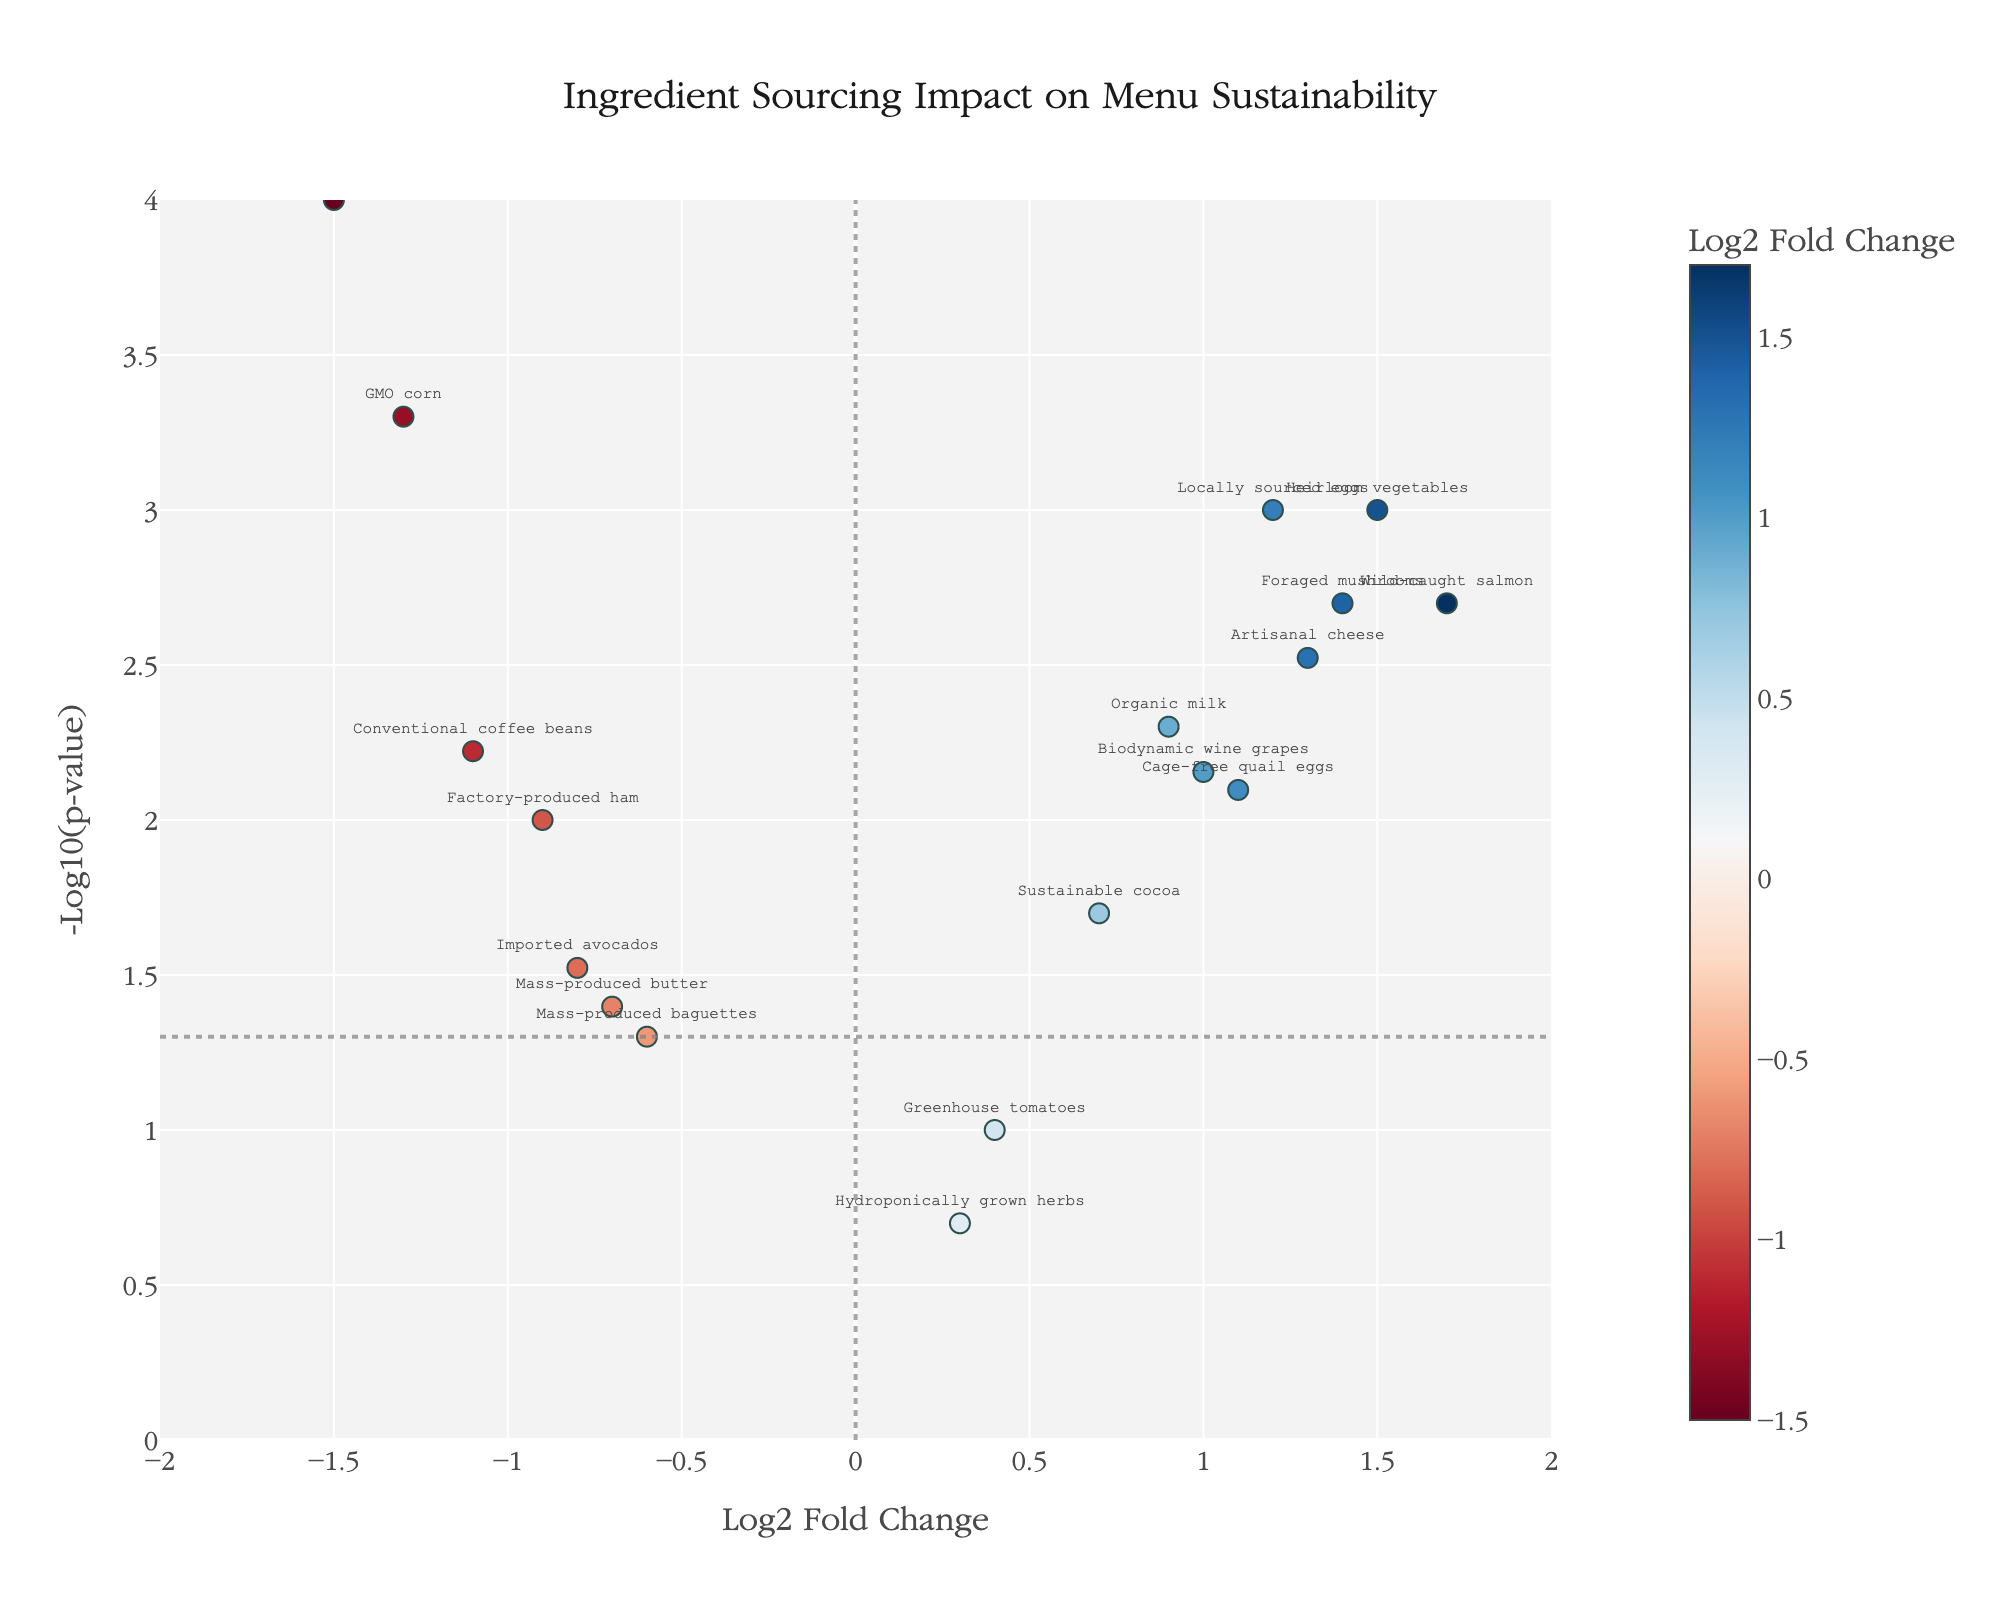What's the title of this figure? The title is typically positioned at the top center of the figure. The text in this position is "Ingredient Sourcing Impact on Menu Sustainability"
Answer: Ingredient Sourcing Impact on Menu Sustainability On which axis can I find the "Log2 Fold Change"? The 'Log2 Fold Change' is mentioned on one of the axis titles. The x-axis title is "Log2 Fold Change".
Answer: X-axis Which ingredient has the highest log2FoldChange value? By inspecting the x-axis, the ingredient with the highest positive value on the rightmost side is "Wild-caught salmon" with a log2FoldChange of 1.7
Answer: Wild-caught salmon Which ingredient has the most significant negative impact according to this plot? Looking at the values most to the left on the x-axis and highest on the y-axis (indicating higher significance), "Factory-farmed chicken" at a log2FoldChange of -1.5 and a very low p-value is most negatively impacting
Answer: Factory-farmed chicken How many ingredients have a p-value less than 0.05? A horizontal line marks the p-value threshold of 0.05, represented by -log10(0.05) ≈ 1.3 on the y-axis. Count the number of points above this line and mark horizontal lines crossing this threshold
Answer: 14 Which ingredient is most far from the origin? The farthest point from both the axes intersection (origin) is "Wild-caught salmon" on the positive x-axis and high y-axis due to its high log2Fold change and low p-value
Answer: Wild-caught salmon Compare "Locally sourced eggs" and "Mass-produced baguettes". Which one has a greater impact on menu sustainability? "Locally sourced eggs" with a log2FoldChange of 1.2 and a low p-value (higher y-axis position) has a more significant positive impact compared to "Mass-produced baguettes" with a log2FoldChange of -0.6 and higher p-value (lower y-axis position) that indicates a less significant negative impact
Answer: Locally sourced eggs What is the y-axis value corresponding to the p-value threshold of 0.05? The threshold is represented as -log10(0.05), and taking the logarithm gives approximately 1.3 on the y-axis
Answer: About 1.3 